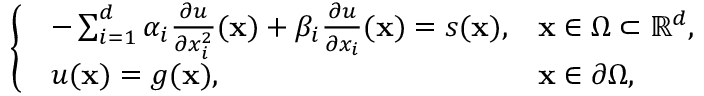Convert formula to latex. <formula><loc_0><loc_0><loc_500><loc_500>\left \{ \begin{array} { l l } { \begin{array} { l l } { - \sum _ { i = 1 } ^ { d } \alpha _ { i } \frac { \partial u } { \partial x _ { i } ^ { 2 } } ( x ) + \beta _ { i } \frac { \partial u } { \partial x _ { i } } ( x ) = s ( x ) , } & { x \in \Omega \subset \mathbb { R } ^ { d } , } \\ { u ( x ) = g ( x ) , } & { x \in \partial \Omega , } \end{array} } \end{array}</formula> 